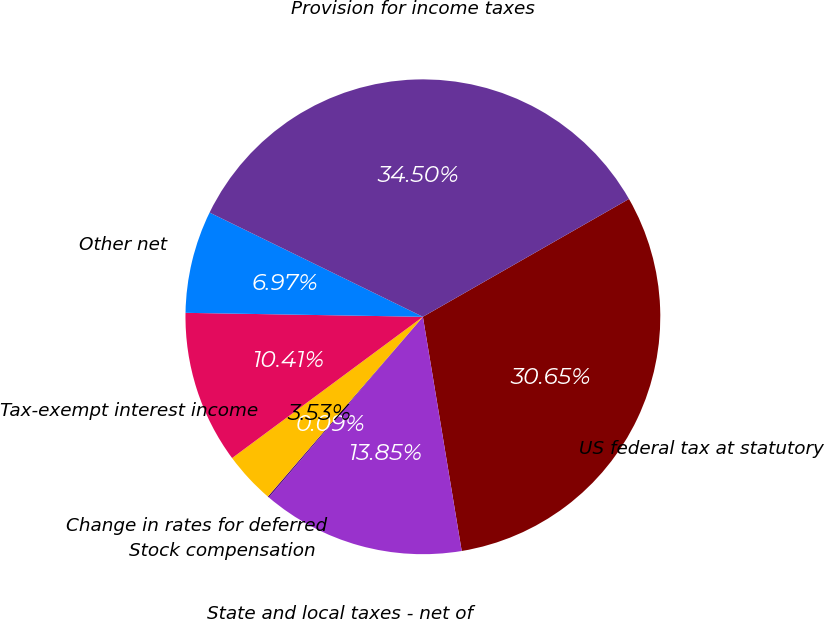<chart> <loc_0><loc_0><loc_500><loc_500><pie_chart><fcel>US federal tax at statutory<fcel>State and local taxes - net of<fcel>Stock compensation<fcel>Change in rates for deferred<fcel>Tax-exempt interest income<fcel>Other net<fcel>Provision for income taxes<nl><fcel>30.65%<fcel>13.85%<fcel>0.09%<fcel>3.53%<fcel>10.41%<fcel>6.97%<fcel>34.5%<nl></chart> 